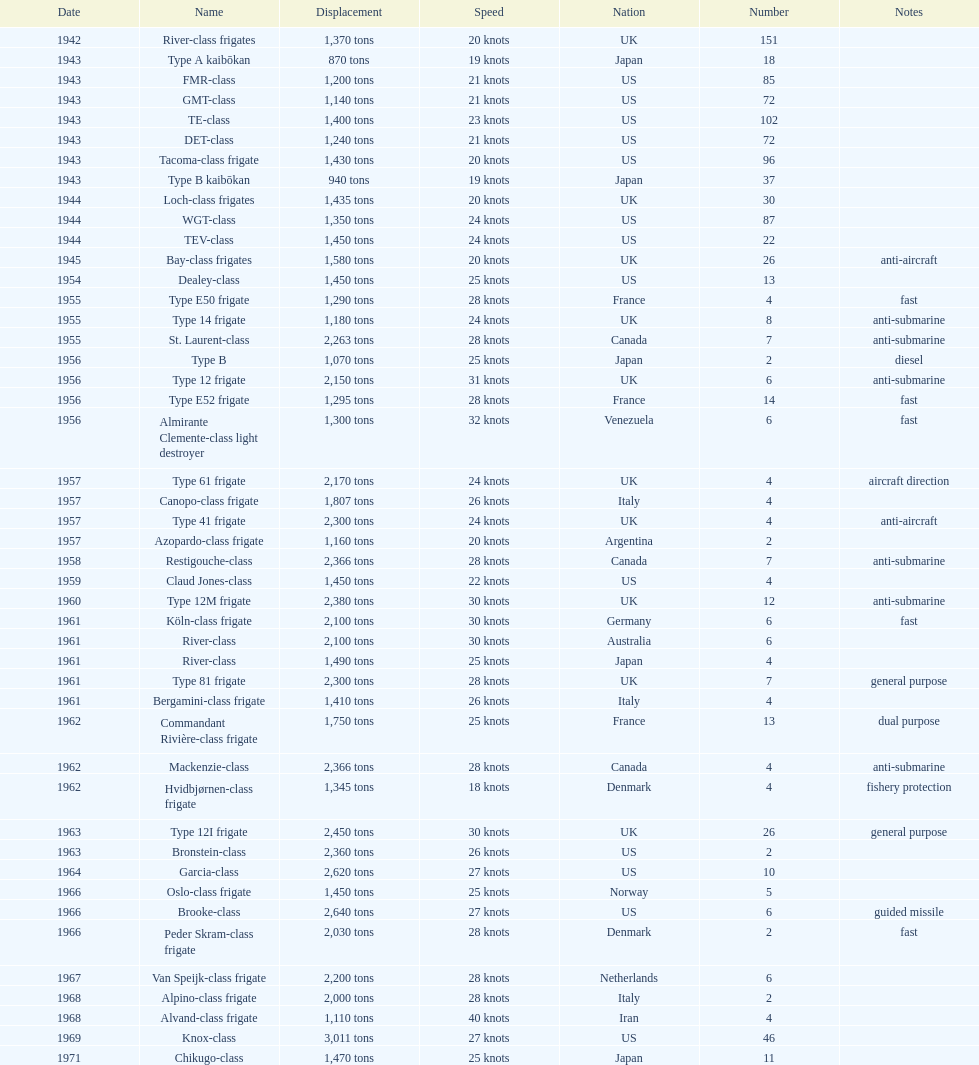What is the difference in speed for the gmt-class and the te-class? 2 knots. 